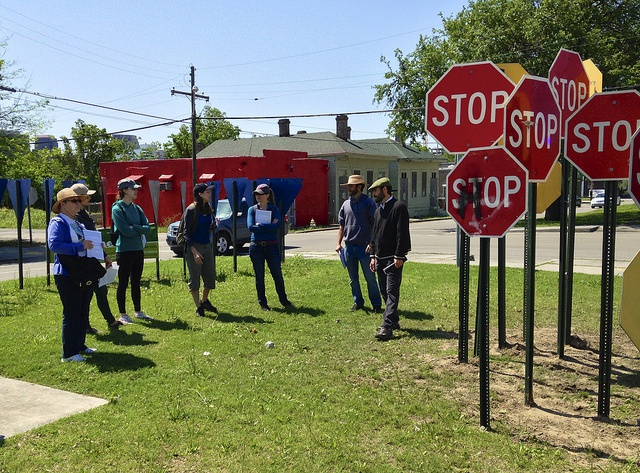Describe the objects in this image and their specific colors. I can see stop sign in lightblue, maroon, darkgray, and brown tones, stop sign in lightblue, maroon, darkgray, black, and gray tones, stop sign in lightblue, maroon, and gray tones, people in lightblue, black, gray, darkgreen, and olive tones, and people in lightblue, black, navy, and gray tones in this image. 